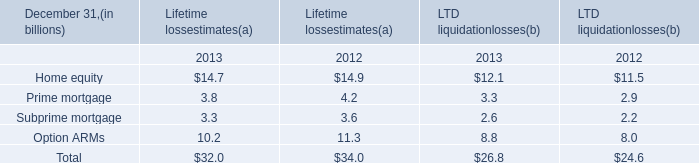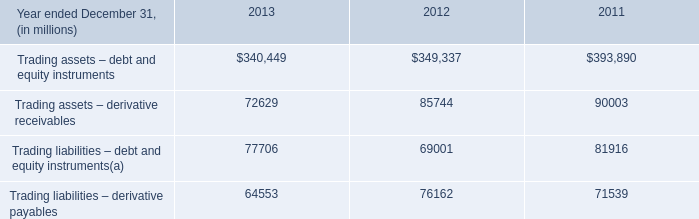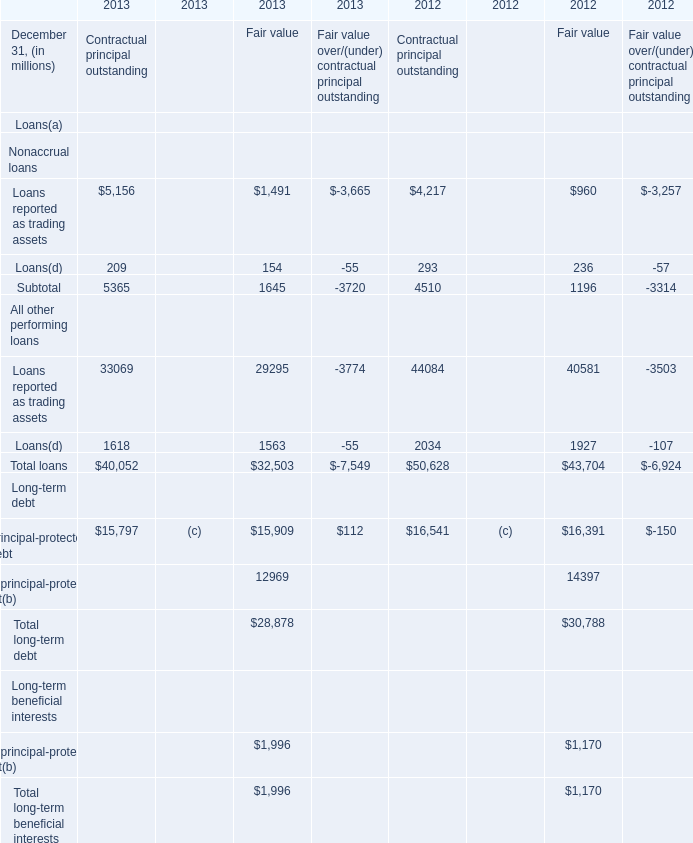What was the total amount of Loans reported as trading assets in the range of 1 and 6000 in 2013 for Contractual principal outstanding? (in million) 
Computations: (5156 + 1491)
Answer: 6647.0. 